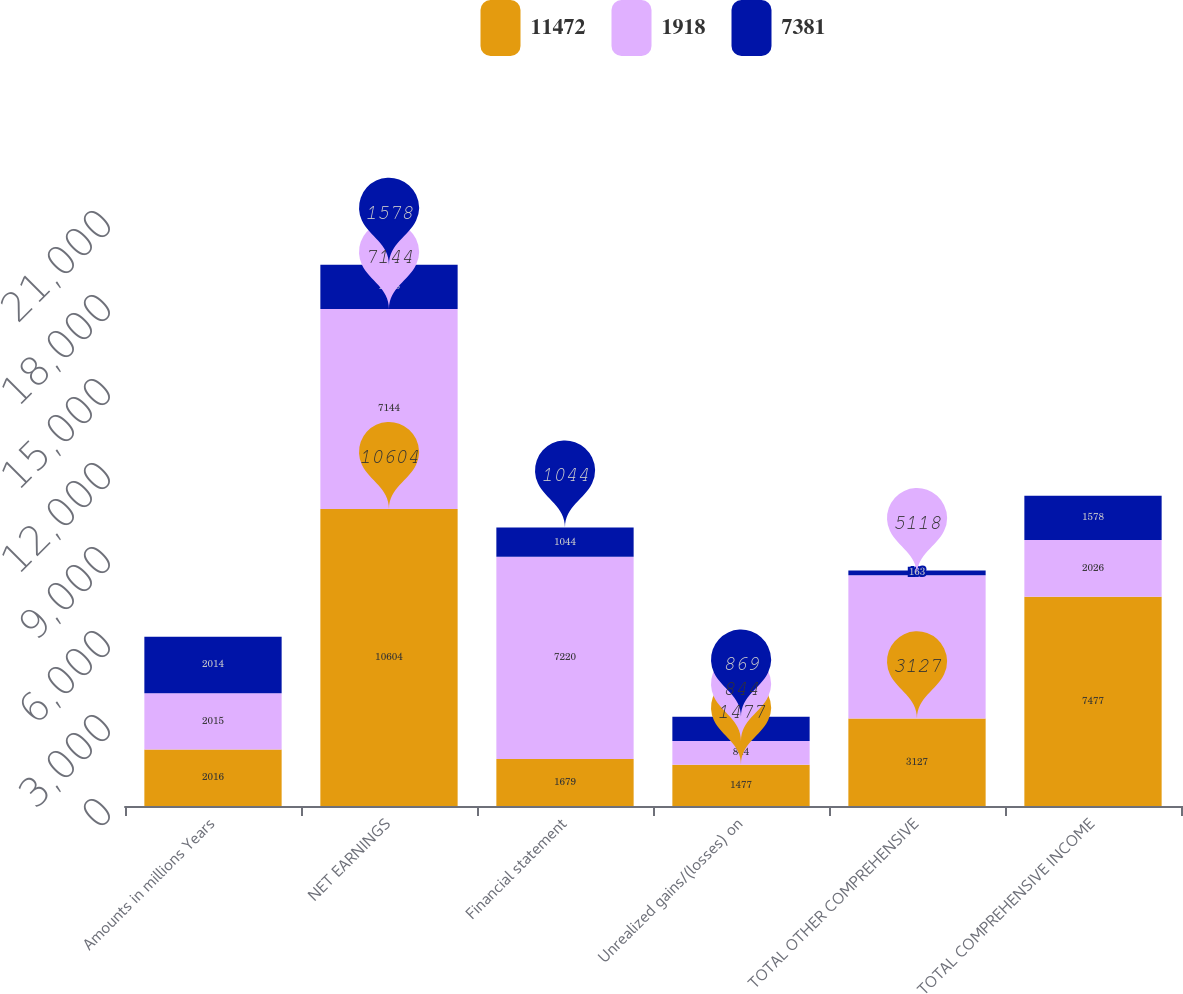Convert chart. <chart><loc_0><loc_0><loc_500><loc_500><stacked_bar_chart><ecel><fcel>Amounts in millions Years<fcel>NET EARNINGS<fcel>Financial statement<fcel>Unrealized gains/(losses) on<fcel>TOTAL OTHER COMPREHENSIVE<fcel>TOTAL COMPREHENSIVE INCOME<nl><fcel>11472<fcel>2016<fcel>10604<fcel>1679<fcel>1477<fcel>3127<fcel>7477<nl><fcel>1918<fcel>2015<fcel>7144<fcel>7220<fcel>844<fcel>5118<fcel>2026<nl><fcel>7381<fcel>2014<fcel>1578<fcel>1044<fcel>869<fcel>163<fcel>1578<nl></chart> 